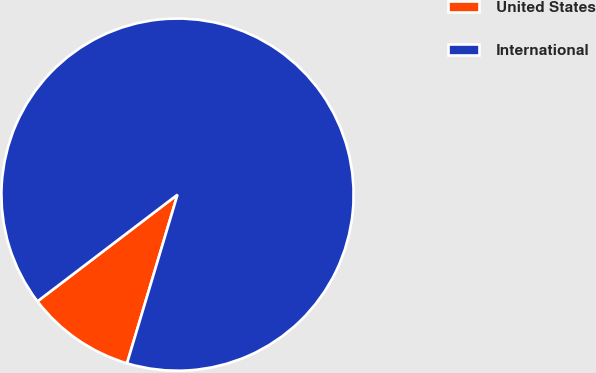Convert chart. <chart><loc_0><loc_0><loc_500><loc_500><pie_chart><fcel>United States<fcel>International<nl><fcel>10.01%<fcel>89.99%<nl></chart> 